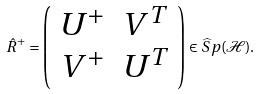Convert formula to latex. <formula><loc_0><loc_0><loc_500><loc_500>\hat { R } ^ { + } = \left ( \begin{array} { c c } U ^ { + } & V ^ { T } \\ V ^ { + } & U ^ { T } \end{array} \right ) \in \widehat { S } p ( \mathcal { H } ) .</formula> 